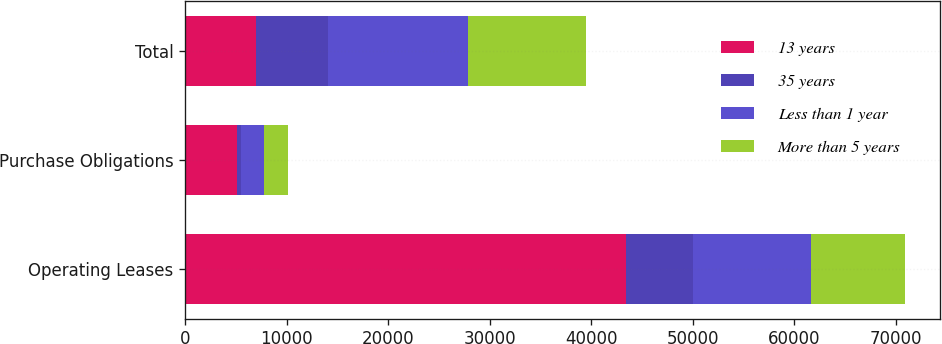Convert chart to OTSL. <chart><loc_0><loc_0><loc_500><loc_500><stacked_bar_chart><ecel><fcel>Operating Leases<fcel>Purchase Obligations<fcel>Total<nl><fcel>13 years<fcel>43438<fcel>5078<fcel>7003<nl><fcel>35 years<fcel>6581<fcel>422<fcel>7003<nl><fcel>Less than 1 year<fcel>11582<fcel>2251<fcel>13833<nl><fcel>More than 5 years<fcel>9263<fcel>2405<fcel>11668<nl></chart> 